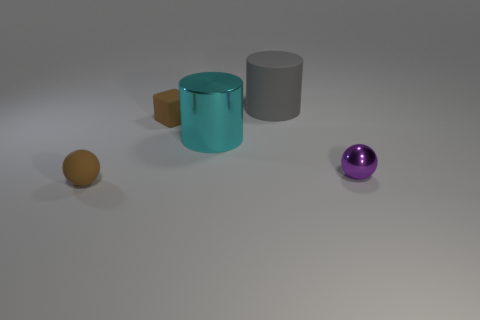Add 4 tiny rubber things. How many objects exist? 9 Subtract all spheres. How many objects are left? 3 Subtract all spheres. Subtract all small balls. How many objects are left? 1 Add 1 metal objects. How many metal objects are left? 3 Add 3 cyan metal cylinders. How many cyan metal cylinders exist? 4 Subtract 0 brown cylinders. How many objects are left? 5 